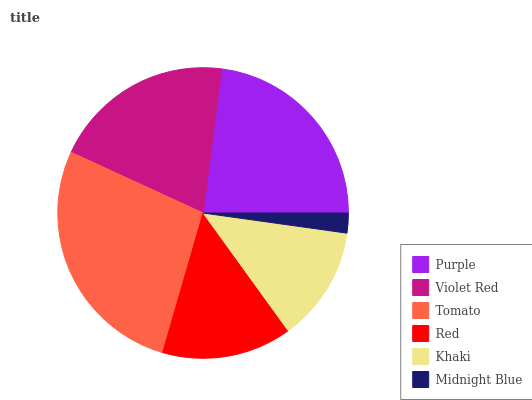Is Midnight Blue the minimum?
Answer yes or no. Yes. Is Tomato the maximum?
Answer yes or no. Yes. Is Violet Red the minimum?
Answer yes or no. No. Is Violet Red the maximum?
Answer yes or no. No. Is Purple greater than Violet Red?
Answer yes or no. Yes. Is Violet Red less than Purple?
Answer yes or no. Yes. Is Violet Red greater than Purple?
Answer yes or no. No. Is Purple less than Violet Red?
Answer yes or no. No. Is Violet Red the high median?
Answer yes or no. Yes. Is Red the low median?
Answer yes or no. Yes. Is Midnight Blue the high median?
Answer yes or no. No. Is Tomato the low median?
Answer yes or no. No. 